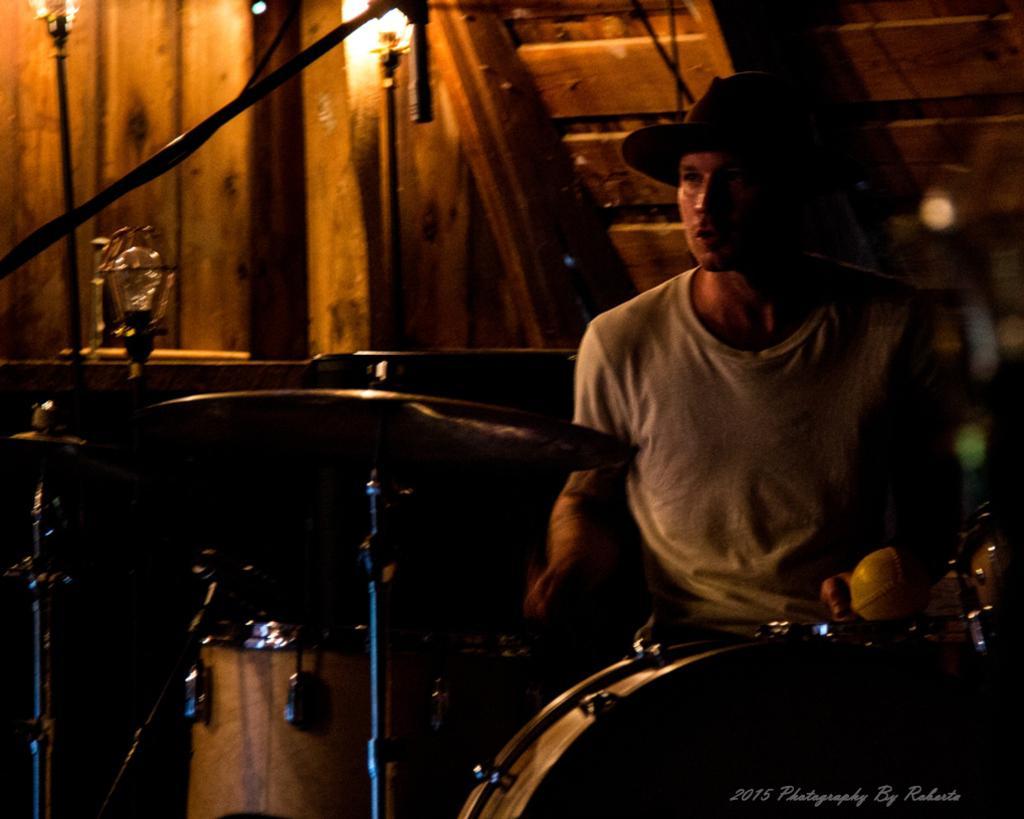How would you summarize this image in a sentence or two? This image is taken indoors. In the background there is a wooden wall. On the right side of the image a man is sitting on the chair. At the bottom of the image there are a few drums and musical instruments. 